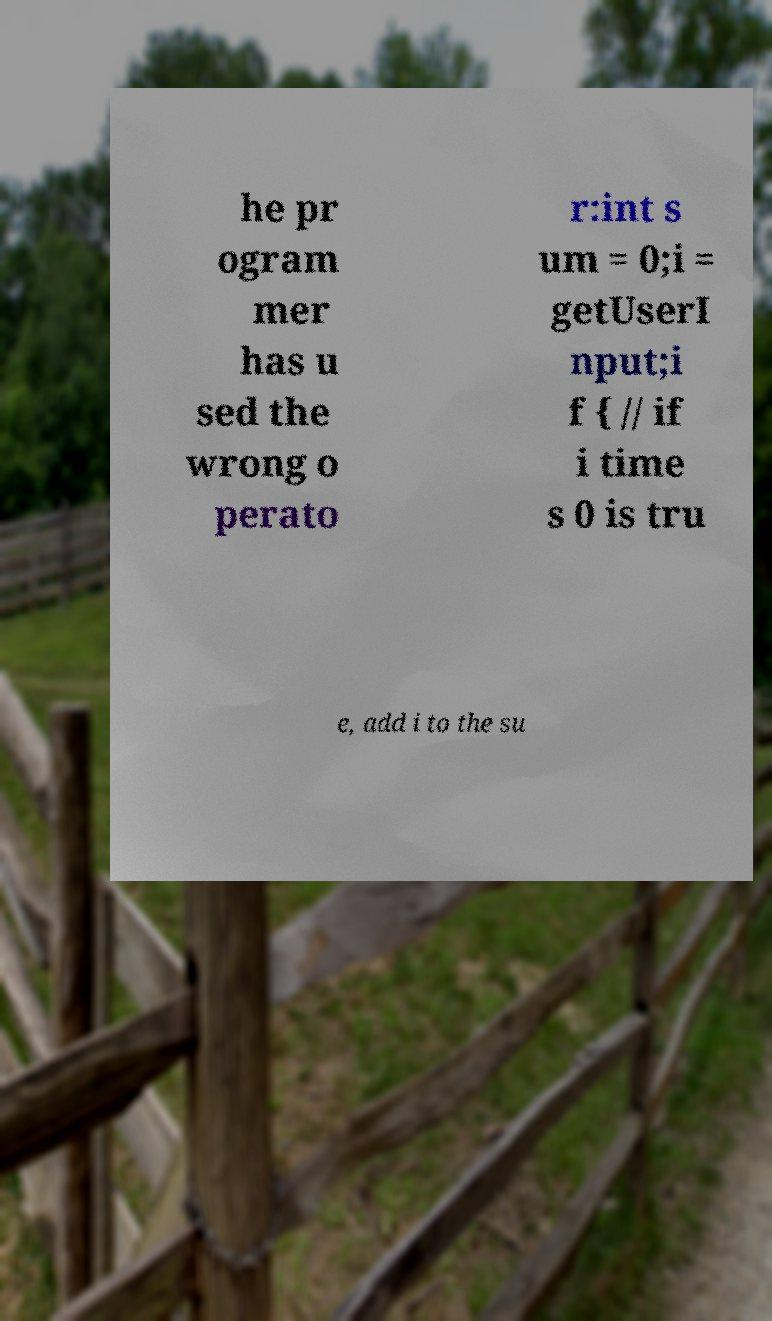Please read and relay the text visible in this image. What does it say? he pr ogram mer has u sed the wrong o perato r:int s um = 0;i = getUserI nput;i f { // if i time s 0 is tru e, add i to the su 